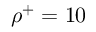<formula> <loc_0><loc_0><loc_500><loc_500>\rho ^ { + } = 1 0 \</formula> 